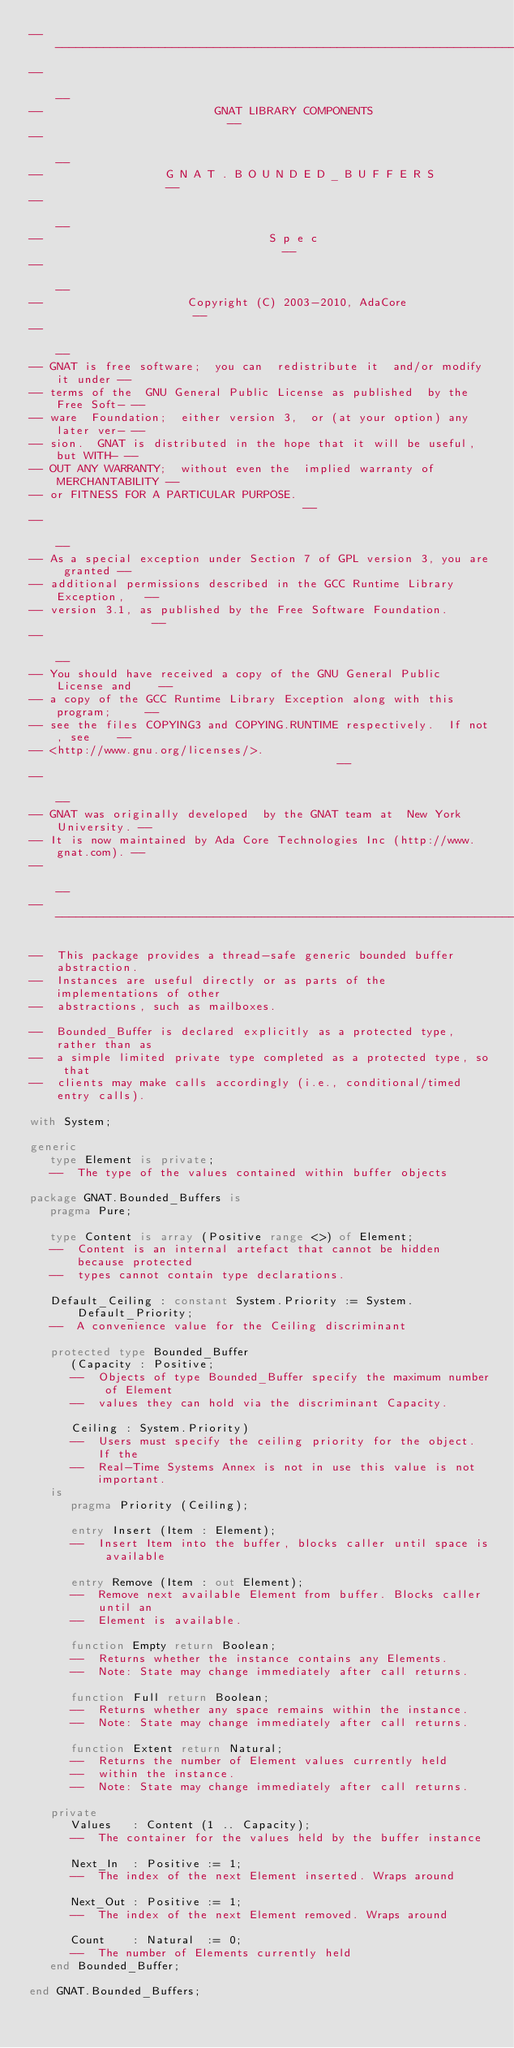Convert code to text. <code><loc_0><loc_0><loc_500><loc_500><_Ada_>------------------------------------------------------------------------------
--                                                                          --
--                         GNAT LIBRARY COMPONENTS                          --
--                                                                          --
--                  G N A T . B O U N D E D _ B U F F E R S                 --
--                                                                          --
--                                 S p e c                                  --
--                                                                          --
--                     Copyright (C) 2003-2010, AdaCore                     --
--                                                                          --
-- GNAT is free software;  you can  redistribute it  and/or modify it under --
-- terms of the  GNU General Public License as published  by the Free Soft- --
-- ware  Foundation;  either version 3,  or (at your option) any later ver- --
-- sion.  GNAT is distributed in the hope that it will be useful, but WITH- --
-- OUT ANY WARRANTY;  without even the  implied warranty of MERCHANTABILITY --
-- or FITNESS FOR A PARTICULAR PURPOSE.                                     --
--                                                                          --
-- As a special exception under Section 7 of GPL version 3, you are granted --
-- additional permissions described in the GCC Runtime Library Exception,   --
-- version 3.1, as published by the Free Software Foundation.               --
--                                                                          --
-- You should have received a copy of the GNU General Public License and    --
-- a copy of the GCC Runtime Library Exception along with this program;     --
-- see the files COPYING3 and COPYING.RUNTIME respectively.  If not, see    --
-- <http://www.gnu.org/licenses/>.                                          --
--                                                                          --
-- GNAT was originally developed  by the GNAT team at  New York University. --
-- It is now maintained by Ada Core Technologies Inc (http://www.gnat.com). --
--                                                                          --
------------------------------------------------------------------------------

--  This package provides a thread-safe generic bounded buffer abstraction.
--  Instances are useful directly or as parts of the implementations of other
--  abstractions, such as mailboxes.

--  Bounded_Buffer is declared explicitly as a protected type, rather than as
--  a simple limited private type completed as a protected type, so that
--  clients may make calls accordingly (i.e., conditional/timed entry calls).

with System;

generic
   type Element is private;
   --  The type of the values contained within buffer objects

package GNAT.Bounded_Buffers is
   pragma Pure;

   type Content is array (Positive range <>) of Element;
   --  Content is an internal artefact that cannot be hidden because protected
   --  types cannot contain type declarations.

   Default_Ceiling : constant System.Priority := System.Default_Priority;
   --  A convenience value for the Ceiling discriminant

   protected type Bounded_Buffer
      (Capacity : Positive;
      --  Objects of type Bounded_Buffer specify the maximum number of Element
      --  values they can hold via the discriminant Capacity.

      Ceiling : System.Priority)
      --  Users must specify the ceiling priority for the object. If the
      --  Real-Time Systems Annex is not in use this value is not important.
   is
      pragma Priority (Ceiling);

      entry Insert (Item : Element);
      --  Insert Item into the buffer, blocks caller until space is available

      entry Remove (Item : out Element);
      --  Remove next available Element from buffer. Blocks caller until an
      --  Element is available.

      function Empty return Boolean;
      --  Returns whether the instance contains any Elements.
      --  Note: State may change immediately after call returns.

      function Full return Boolean;
      --  Returns whether any space remains within the instance.
      --  Note: State may change immediately after call returns.

      function Extent return Natural;
      --  Returns the number of Element values currently held
      --  within the instance.
      --  Note: State may change immediately after call returns.

   private
      Values   : Content (1 .. Capacity);
      --  The container for the values held by the buffer instance

      Next_In  : Positive := 1;
      --  The index of the next Element inserted. Wraps around

      Next_Out : Positive := 1;
      --  The index of the next Element removed. Wraps around

      Count    : Natural  := 0;
      --  The number of Elements currently held
   end Bounded_Buffer;

end GNAT.Bounded_Buffers;
</code> 